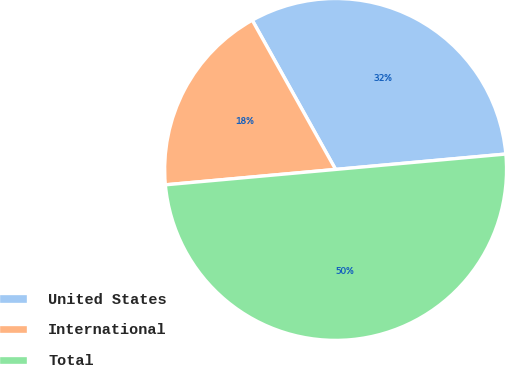<chart> <loc_0><loc_0><loc_500><loc_500><pie_chart><fcel>United States<fcel>International<fcel>Total<nl><fcel>31.67%<fcel>18.33%<fcel>50.0%<nl></chart> 